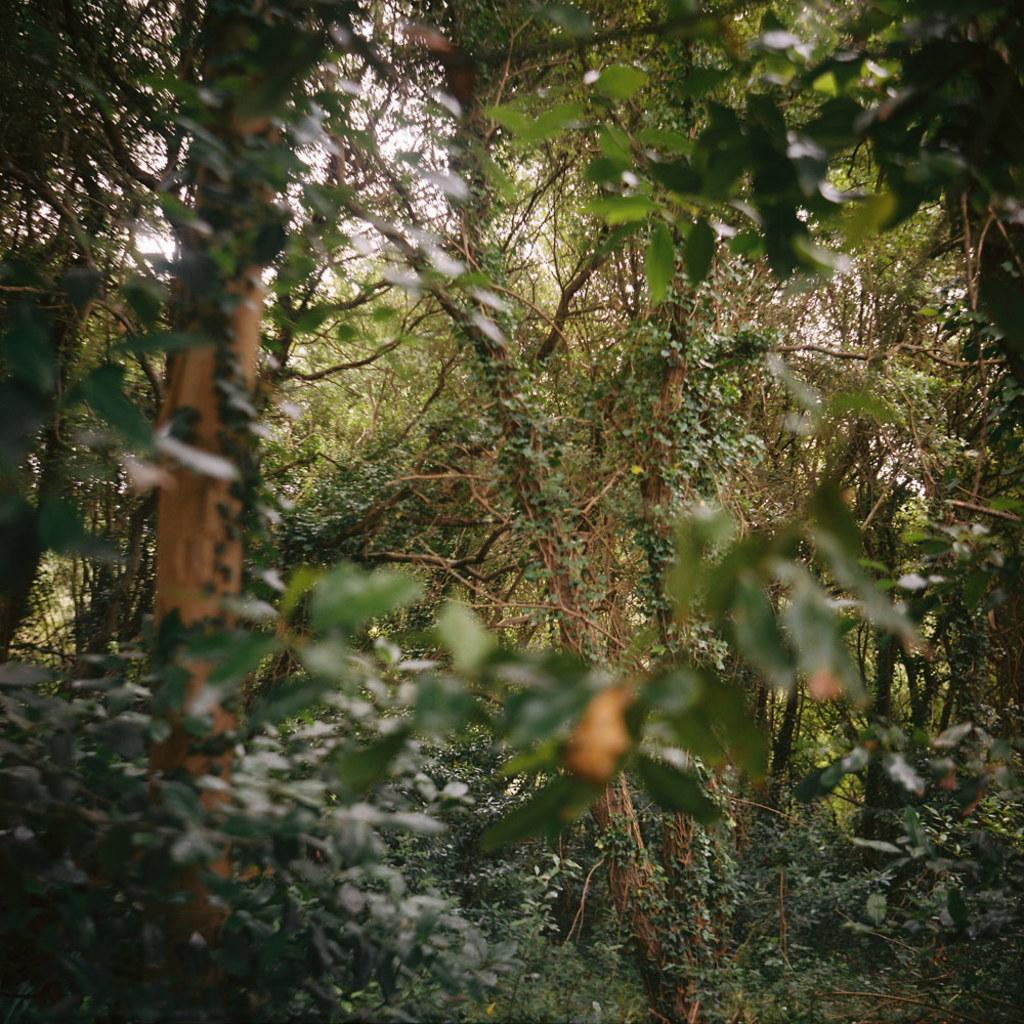What type of vegetation can be seen in the image? There are trees in the image. What type of cactus is present in the image? There is no cactus present in the image; it only features trees. What type of pet can be seen in the image? There is no pet present in the image; it only features trees. 